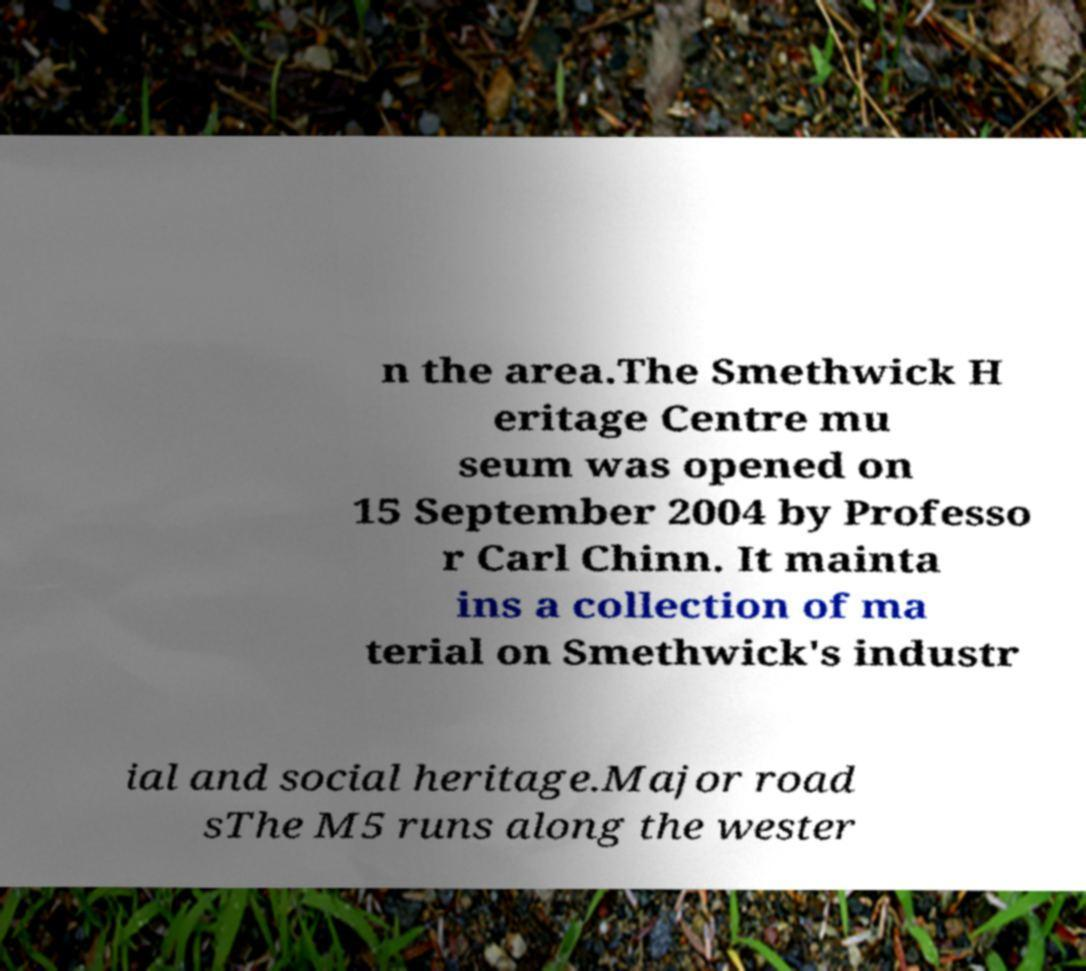There's text embedded in this image that I need extracted. Can you transcribe it verbatim? n the area.The Smethwick H eritage Centre mu seum was opened on 15 September 2004 by Professo r Carl Chinn. It mainta ins a collection of ma terial on Smethwick's industr ial and social heritage.Major road sThe M5 runs along the wester 